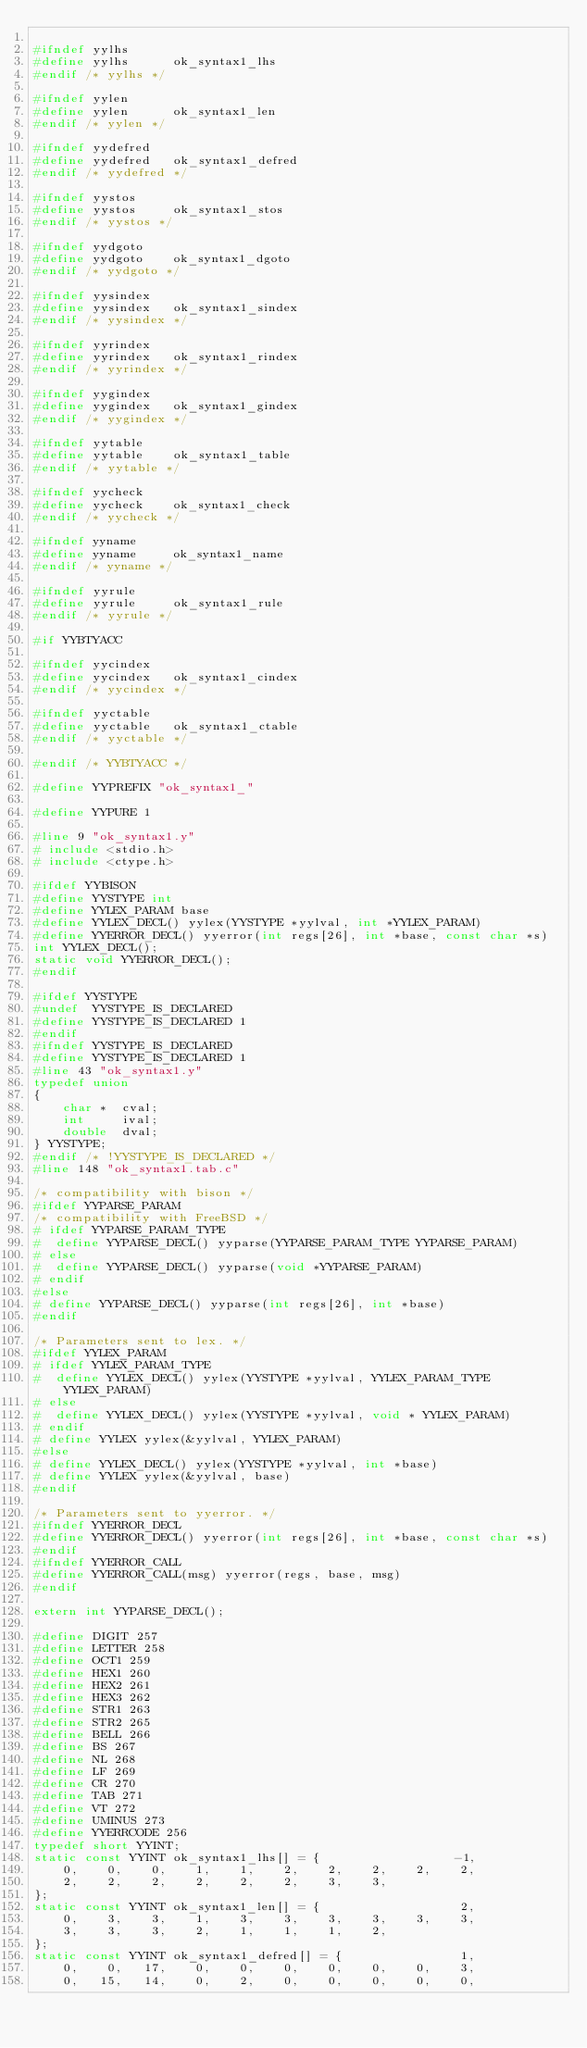Convert code to text. <code><loc_0><loc_0><loc_500><loc_500><_C_>
#ifndef yylhs
#define yylhs      ok_syntax1_lhs
#endif /* yylhs */

#ifndef yylen
#define yylen      ok_syntax1_len
#endif /* yylen */

#ifndef yydefred
#define yydefred   ok_syntax1_defred
#endif /* yydefred */

#ifndef yystos
#define yystos     ok_syntax1_stos
#endif /* yystos */

#ifndef yydgoto
#define yydgoto    ok_syntax1_dgoto
#endif /* yydgoto */

#ifndef yysindex
#define yysindex   ok_syntax1_sindex
#endif /* yysindex */

#ifndef yyrindex
#define yyrindex   ok_syntax1_rindex
#endif /* yyrindex */

#ifndef yygindex
#define yygindex   ok_syntax1_gindex
#endif /* yygindex */

#ifndef yytable
#define yytable    ok_syntax1_table
#endif /* yytable */

#ifndef yycheck
#define yycheck    ok_syntax1_check
#endif /* yycheck */

#ifndef yyname
#define yyname     ok_syntax1_name
#endif /* yyname */

#ifndef yyrule
#define yyrule     ok_syntax1_rule
#endif /* yyrule */

#if YYBTYACC

#ifndef yycindex
#define yycindex   ok_syntax1_cindex
#endif /* yycindex */

#ifndef yyctable
#define yyctable   ok_syntax1_ctable
#endif /* yyctable */

#endif /* YYBTYACC */

#define YYPREFIX "ok_syntax1_"

#define YYPURE 1

#line 9 "ok_syntax1.y"
# include <stdio.h>
# include <ctype.h>

#ifdef YYBISON
#define YYSTYPE int
#define YYLEX_PARAM base
#define YYLEX_DECL() yylex(YYSTYPE *yylval, int *YYLEX_PARAM)
#define YYERROR_DECL() yyerror(int regs[26], int *base, const char *s)
int YYLEX_DECL();
static void YYERROR_DECL();
#endif

#ifdef YYSTYPE
#undef  YYSTYPE_IS_DECLARED
#define YYSTYPE_IS_DECLARED 1
#endif
#ifndef YYSTYPE_IS_DECLARED
#define YYSTYPE_IS_DECLARED 1
#line 43 "ok_syntax1.y"
typedef union
{
    char *	cval;
    int		ival;
    double	dval;
} YYSTYPE;
#endif /* !YYSTYPE_IS_DECLARED */
#line 148 "ok_syntax1.tab.c"

/* compatibility with bison */
#ifdef YYPARSE_PARAM
/* compatibility with FreeBSD */
# ifdef YYPARSE_PARAM_TYPE
#  define YYPARSE_DECL() yyparse(YYPARSE_PARAM_TYPE YYPARSE_PARAM)
# else
#  define YYPARSE_DECL() yyparse(void *YYPARSE_PARAM)
# endif
#else
# define YYPARSE_DECL() yyparse(int regs[26], int *base)
#endif

/* Parameters sent to lex. */
#ifdef YYLEX_PARAM
# ifdef YYLEX_PARAM_TYPE
#  define YYLEX_DECL() yylex(YYSTYPE *yylval, YYLEX_PARAM_TYPE YYLEX_PARAM)
# else
#  define YYLEX_DECL() yylex(YYSTYPE *yylval, void * YYLEX_PARAM)
# endif
# define YYLEX yylex(&yylval, YYLEX_PARAM)
#else
# define YYLEX_DECL() yylex(YYSTYPE *yylval, int *base)
# define YYLEX yylex(&yylval, base)
#endif

/* Parameters sent to yyerror. */
#ifndef YYERROR_DECL
#define YYERROR_DECL() yyerror(int regs[26], int *base, const char *s)
#endif
#ifndef YYERROR_CALL
#define YYERROR_CALL(msg) yyerror(regs, base, msg)
#endif

extern int YYPARSE_DECL();

#define DIGIT 257
#define LETTER 258
#define OCT1 259
#define HEX1 260
#define HEX2 261
#define HEX3 262
#define STR1 263
#define STR2 265
#define BELL 266
#define BS 267
#define NL 268
#define LF 269
#define CR 270
#define TAB 271
#define VT 272
#define UMINUS 273
#define YYERRCODE 256
typedef short YYINT;
static const YYINT ok_syntax1_lhs[] = {                  -1,
    0,    0,    0,    1,    1,    2,    2,    2,    2,    2,
    2,    2,    2,    2,    2,    2,    3,    3,
};
static const YYINT ok_syntax1_len[] = {                   2,
    0,    3,    3,    1,    3,    3,    3,    3,    3,    3,
    3,    3,    3,    2,    1,    1,    1,    2,
};
static const YYINT ok_syntax1_defred[] = {                1,
    0,    0,   17,    0,    0,    0,    0,    0,    0,    3,
    0,   15,   14,    0,    2,    0,    0,    0,    0,    0,</code> 